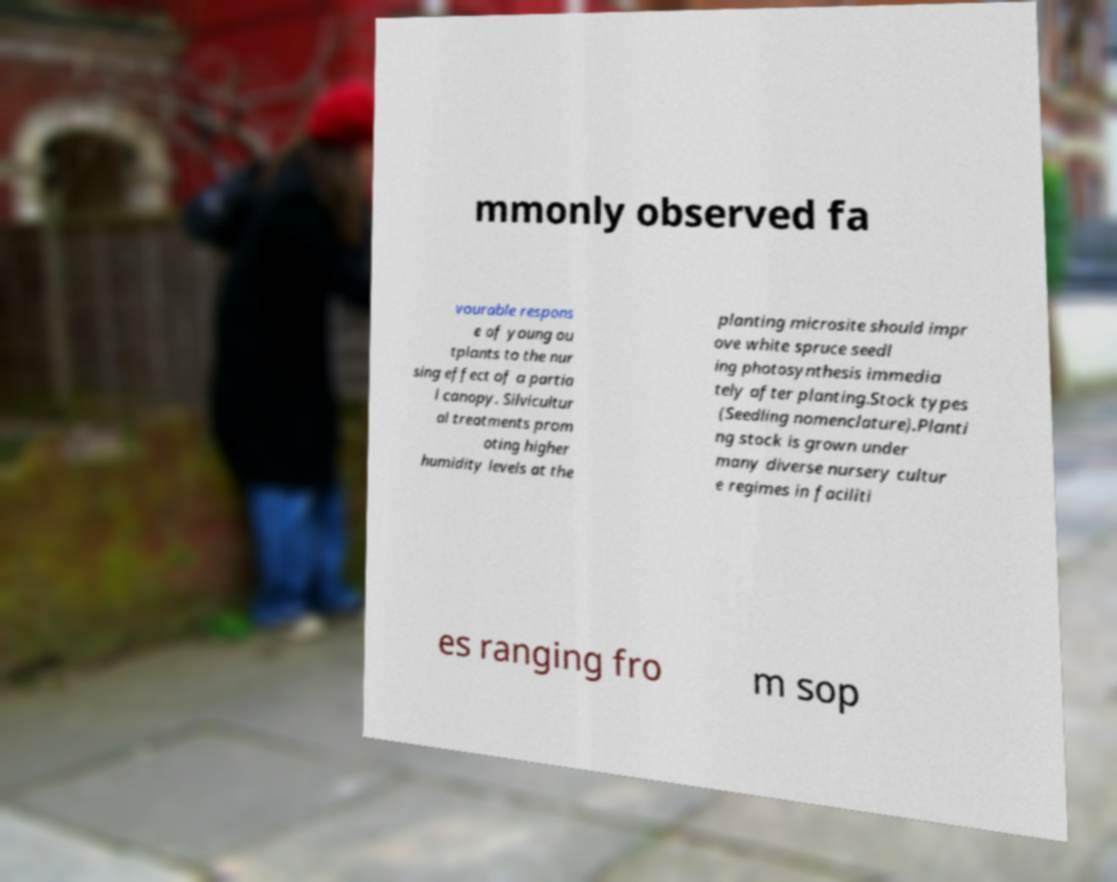I need the written content from this picture converted into text. Can you do that? mmonly observed fa vourable respons e of young ou tplants to the nur sing effect of a partia l canopy. Silvicultur al treatments prom oting higher humidity levels at the planting microsite should impr ove white spruce seedl ing photosynthesis immedia tely after planting.Stock types (Seedling nomenclature).Planti ng stock is grown under many diverse nursery cultur e regimes in faciliti es ranging fro m sop 